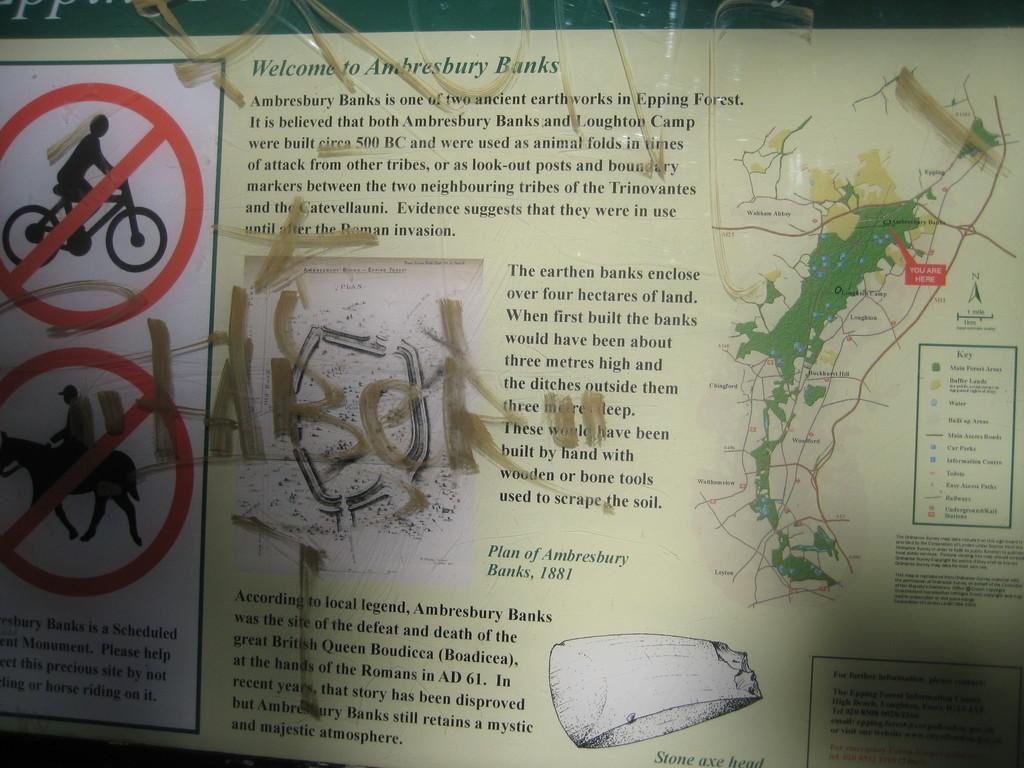<image>
Provide a brief description of the given image. Graffiti is on an informational sign about the Ambresbury Banks. 